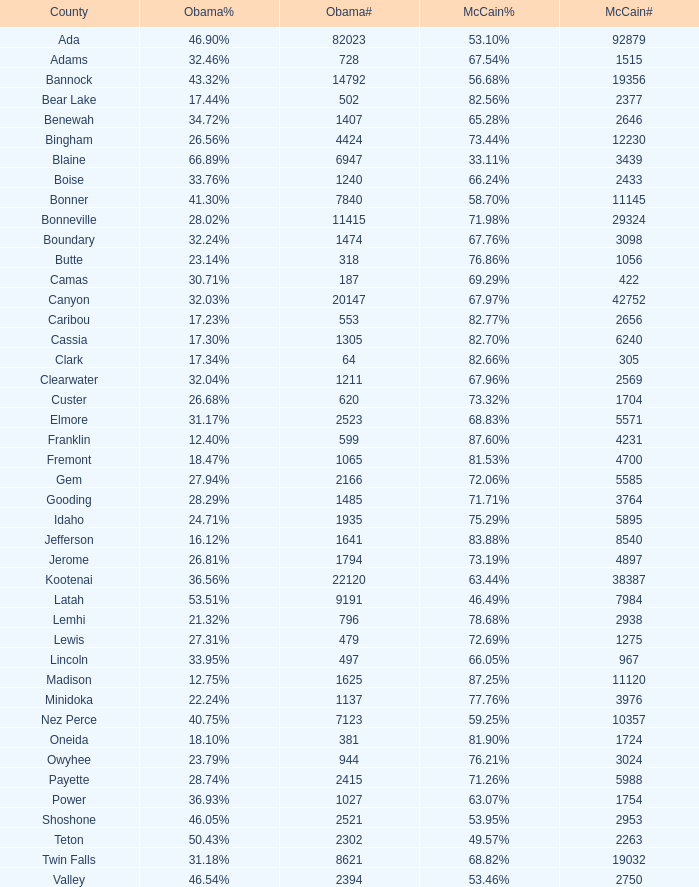What is the maximum McCain population turnout number? 92879.0. 